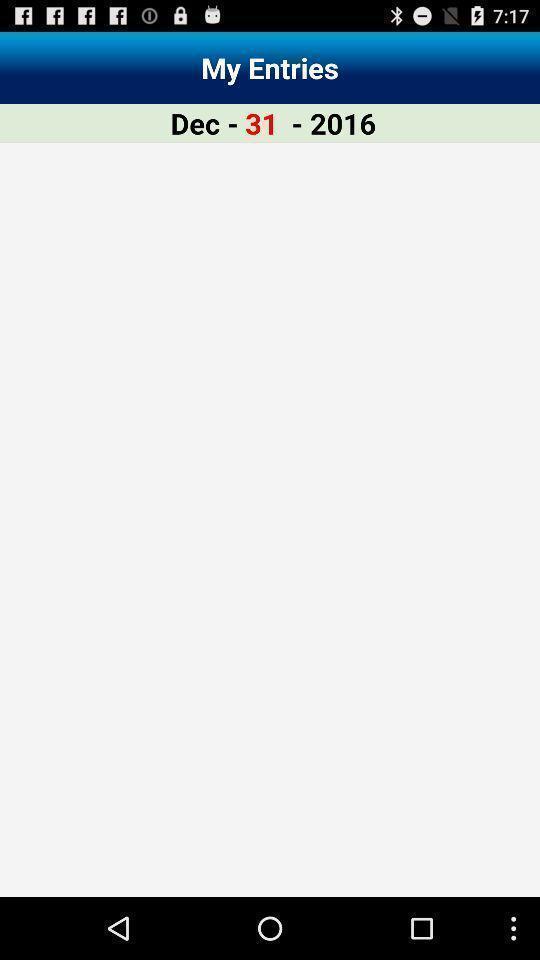Provide a description of this screenshot. Page displaying a date. 